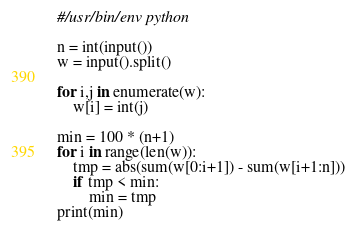Convert code to text. <code><loc_0><loc_0><loc_500><loc_500><_Python_>#/usr/bin/env python

n = int(input())
w = input().split()

for i,j in enumerate(w):
    w[i] = int(j)

min = 100 * (n+1)
for i in range(len(w)):
    tmp = abs(sum(w[0:i+1]) - sum(w[i+1:n]))
    if tmp < min:
        min = tmp
print(min)</code> 